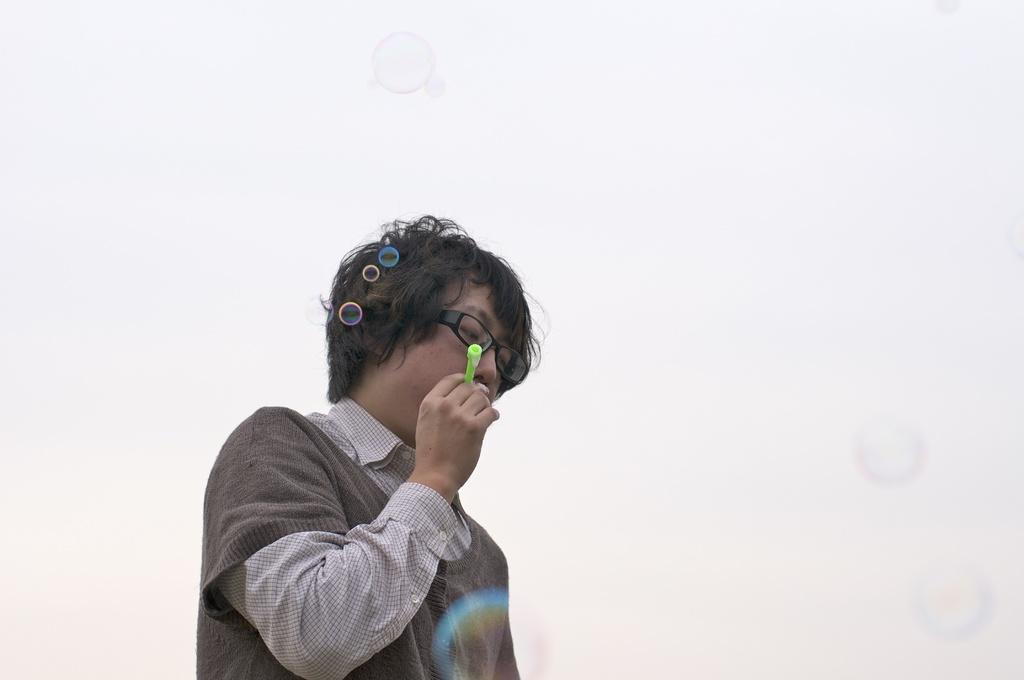Could you give a brief overview of what you see in this image? In this picture we can see a boy wore a spectacle and holding an object with his hand and in the background we can see water bubbles. 